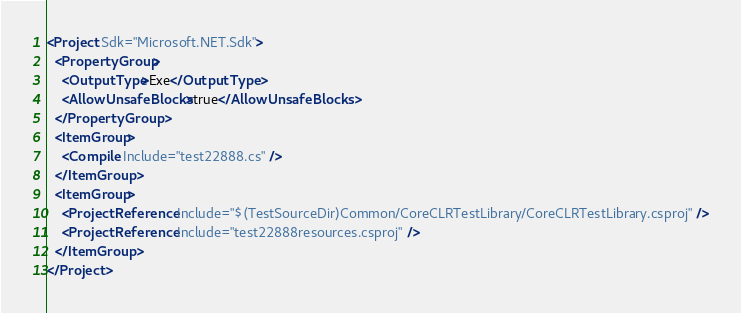<code> <loc_0><loc_0><loc_500><loc_500><_XML_><Project Sdk="Microsoft.NET.Sdk">
  <PropertyGroup>
    <OutputType>Exe</OutputType>
    <AllowUnsafeBlocks>true</AllowUnsafeBlocks>
  </PropertyGroup>
  <ItemGroup>
    <Compile Include="test22888.cs" />
  </ItemGroup>
  <ItemGroup>
    <ProjectReference Include="$(TestSourceDir)Common/CoreCLRTestLibrary/CoreCLRTestLibrary.csproj" />
    <ProjectReference Include="test22888resources.csproj" />
  </ItemGroup>
</Project>
</code> 